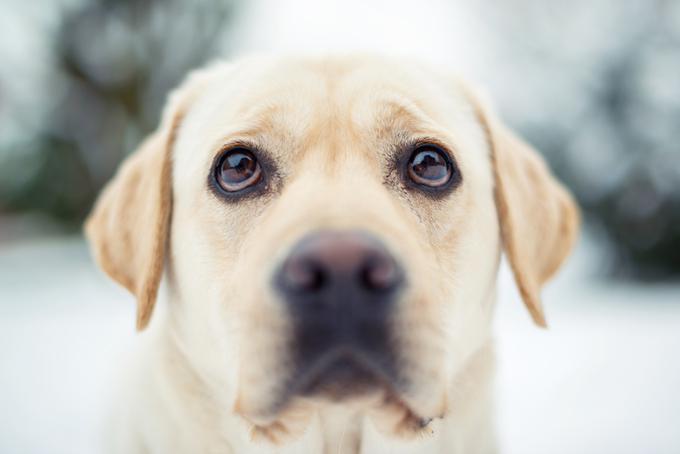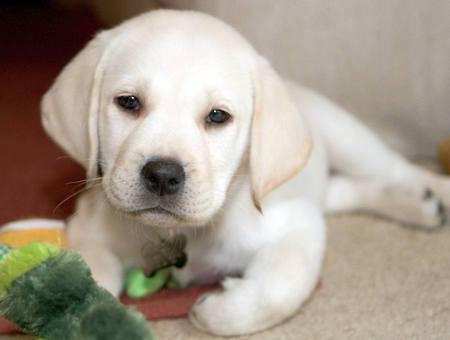The first image is the image on the left, the second image is the image on the right. Assess this claim about the two images: "There are no less than four dogs". Correct or not? Answer yes or no. No. 